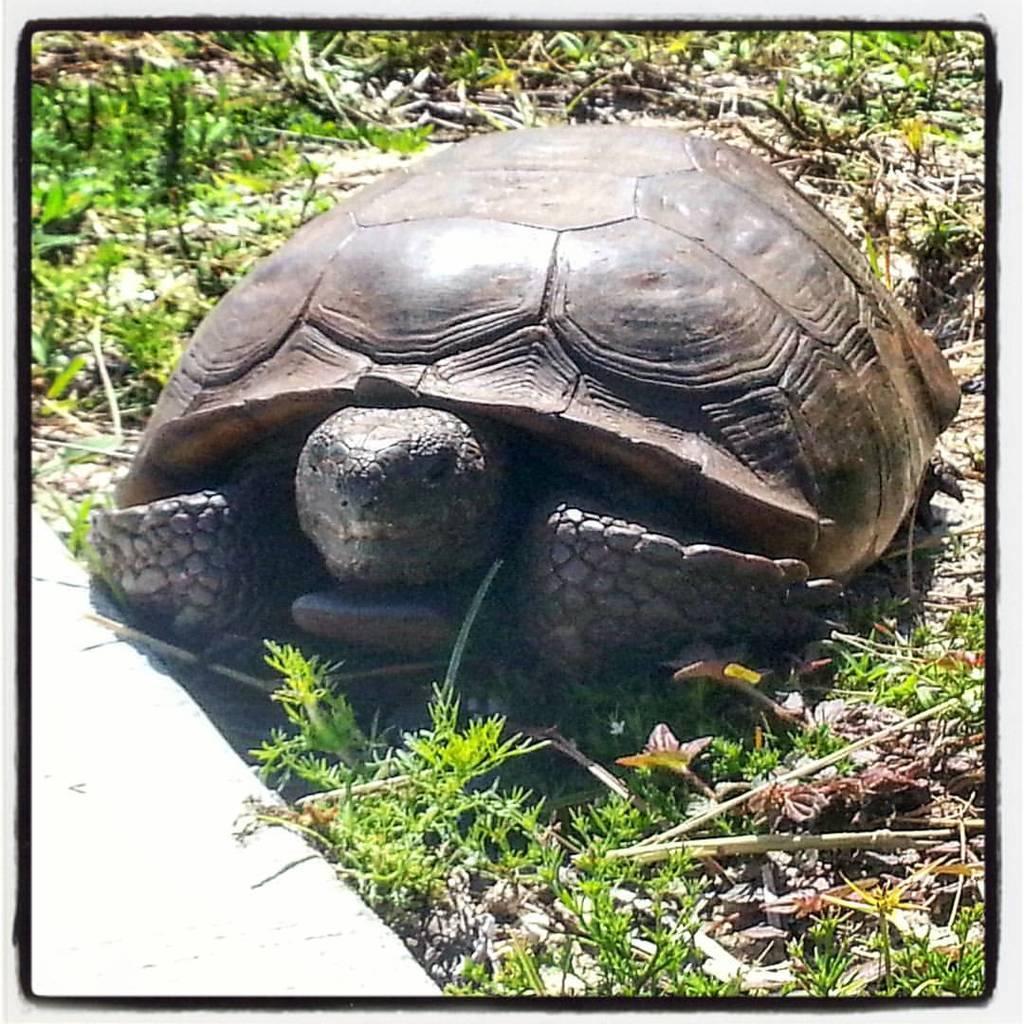Please provide a concise description of this image. This picture is an edited picture. In this picture there is a tortoise in the foreground. At the bottom there are plants. 